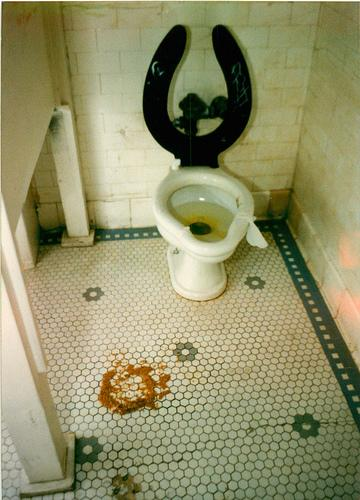Mention something unusual that you see on the floor in the image. There is an orange pile of vomit that appears to have been stepped in. How would you describe the level of privacy offered by the white wood privacy wall in the image? The white wood privacy wall provides limited privacy, as it only covers a small portion of the toilet area. What type of advertisement would this image be unsuitable to promote? A bathroom cleaning product, due to the extreme filth and lack of cleanliness. Can you describe the state of cleanliness for the toilet and the surrounding area featured in the image? The toilet and surrounding area are very dirty, featuring stains, toilet paper, graffiti, and vomit on the floor. Which object appears to be in the worst condition in the image? The dirty toilet with a black seat left up and toilet paper stuck to it. List three noticeable things about the dirty toilet in the image, avoiding general observations. Black seat left up, toilet paper stuck to it, and graffiti on the white surface. What color is the flower pattern on the tiles around the toilet, and what is its predominant shape? The flower pattern is green and resembles a hexagon shape. Briefly describe the condition of the wall and the floor in the image. The wall is dirty and has white and green tiles, while the floor features a hexagon pattern with mud and vomit nearby. Choose the most accurate description for the toilet in the image. A dirty white toilet with a black seat left up and toilet paper stuck to it, surrounded by a filthy bathroom environment. 